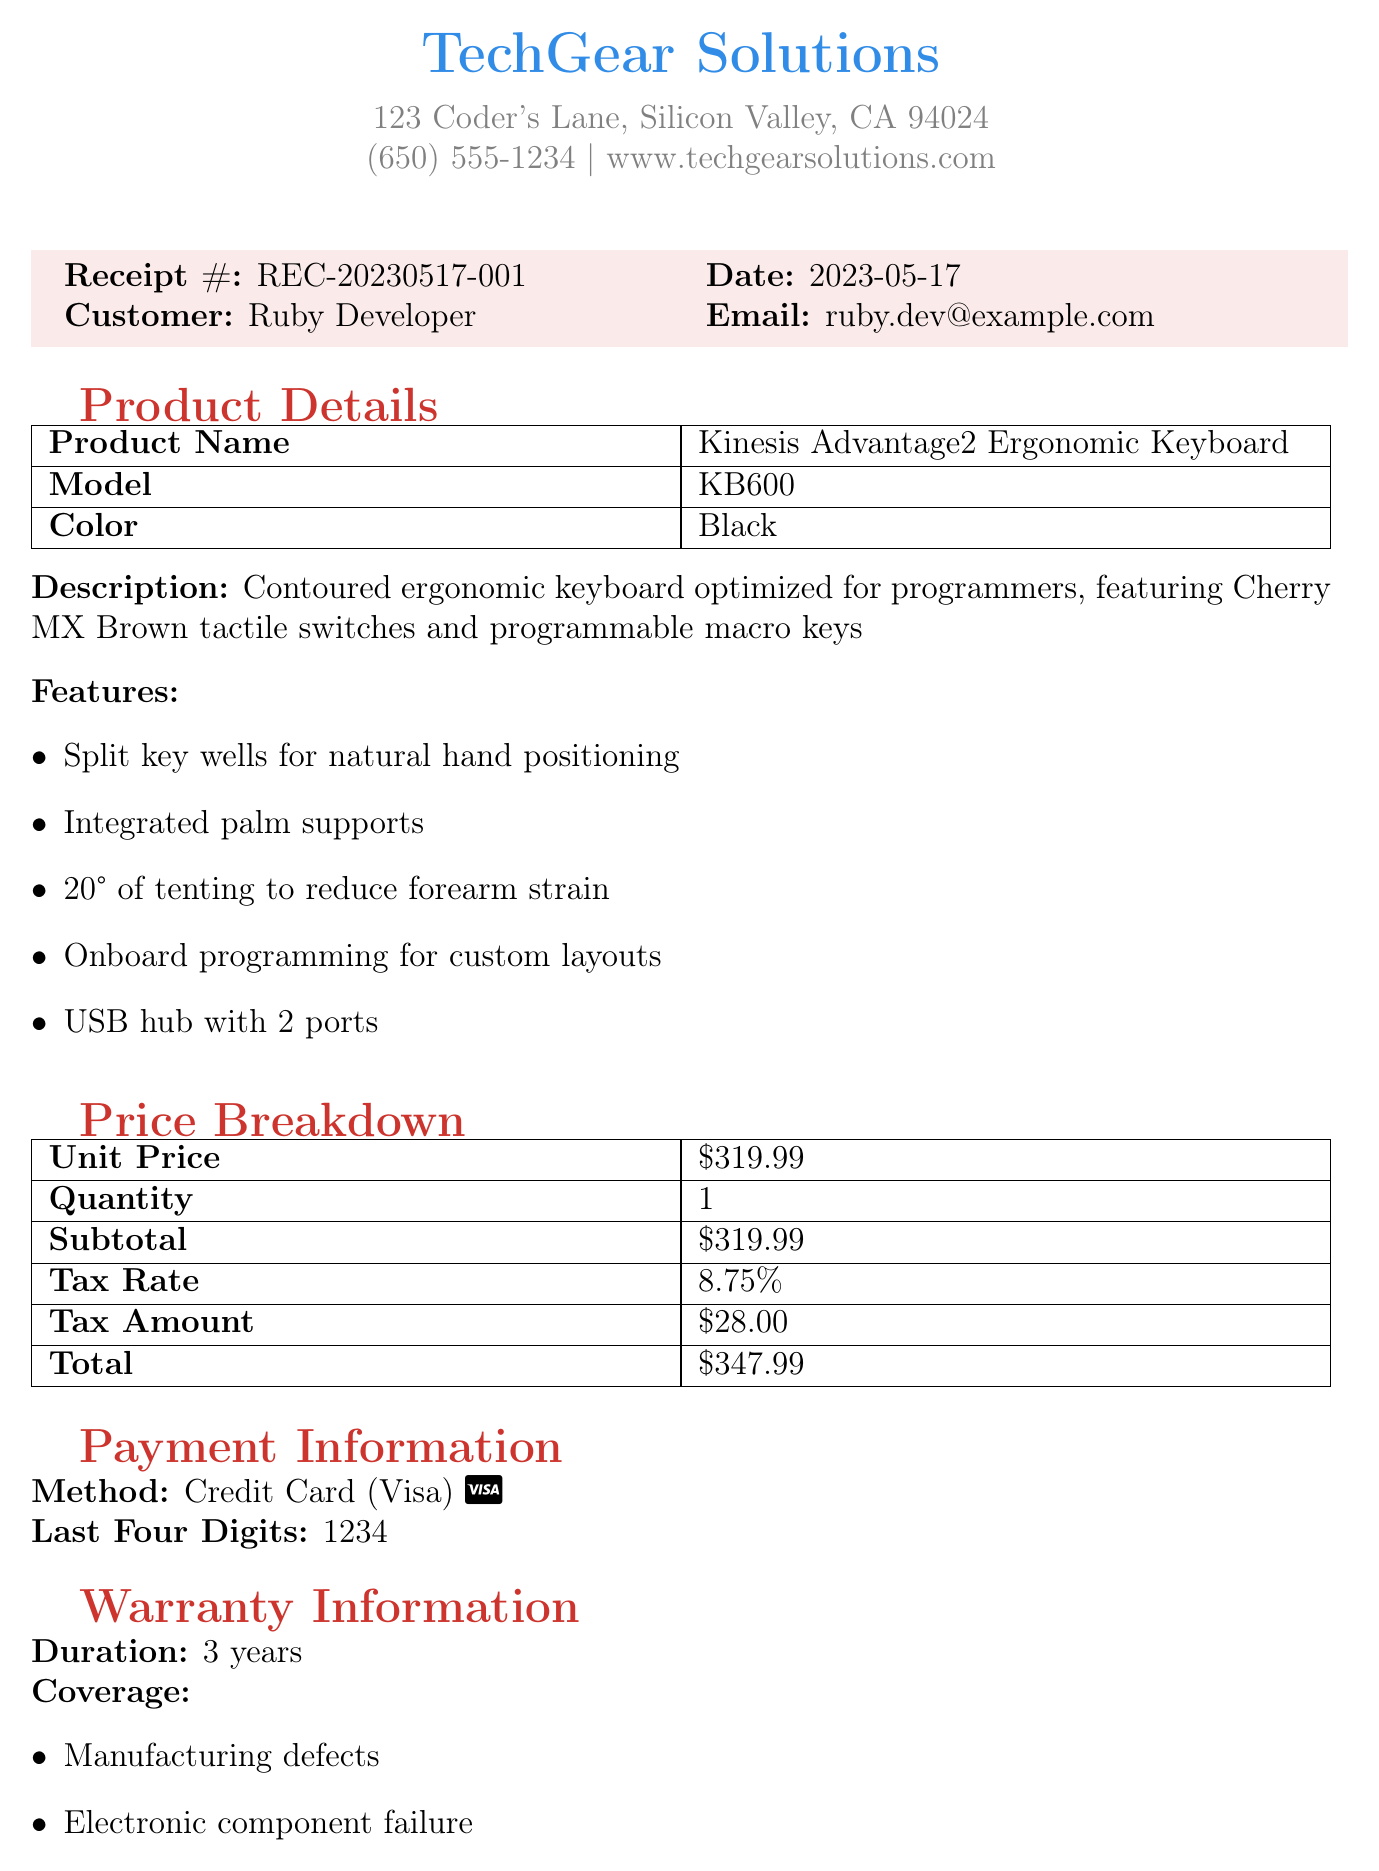What is the receipt number? The receipt number is specified under the receipt details section of the document, which is REC-20230517-001.
Answer: REC-20230517-001 What is the date of purchase? The purchase date can be found next to the receipt number in the document, which is 2023-05-17.
Answer: 2023-05-17 Who is the vendor? The vendor's name is mentioned at the top of the document, which is TechGear Solutions.
Answer: TechGear Solutions What is the unit price of the keyboard? The unit price is detailed in the price breakdown section, which states $319.99.
Answer: $319.99 How long is the warranty duration? The warranty information states the duration as 3 years.
Answer: 3 years What is covered under the warranty? The warranty coverage lists specific defects, including manufacturing faults and electronic component failure.
Answer: Manufacturing defects, Electronic component failure, Key switch malfunction What is the return policy? The return policy is described in the additional information section, indicating a 30-day money-back guarantee.
Answer: 30-day money-back guarantee What ergonomic benefit does the keyboard offer? The document specifies one ergonomic benefit as reducing wrist strain and improving typing comfort for long coding sessions.
Answer: Reduces wrist strain and improves typing comfort What is the support contact email? The support contact information is provided under warranty details, which is support@techgearsolutions.com.
Answer: support@techgearsolutions.com 